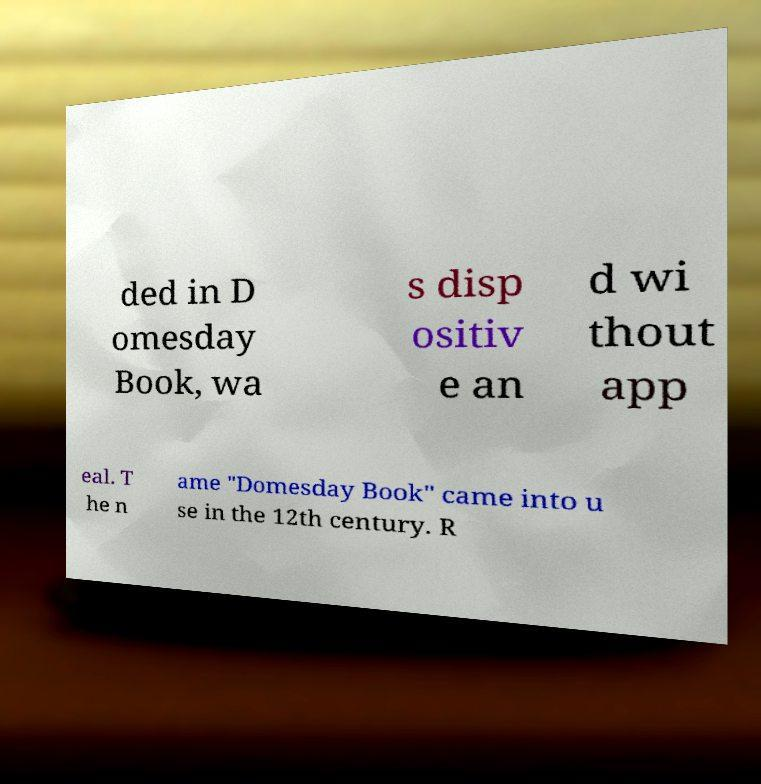Could you assist in decoding the text presented in this image and type it out clearly? ded in D omesday Book, wa s disp ositiv e an d wi thout app eal. T he n ame "Domesday Book" came into u se in the 12th century. R 